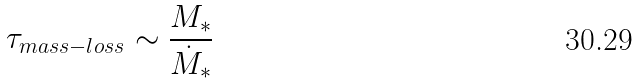Convert formula to latex. <formula><loc_0><loc_0><loc_500><loc_500>\tau _ { m a s s - l o s s } \sim \frac { M _ { * } } { \dot { M } _ { * } }</formula> 